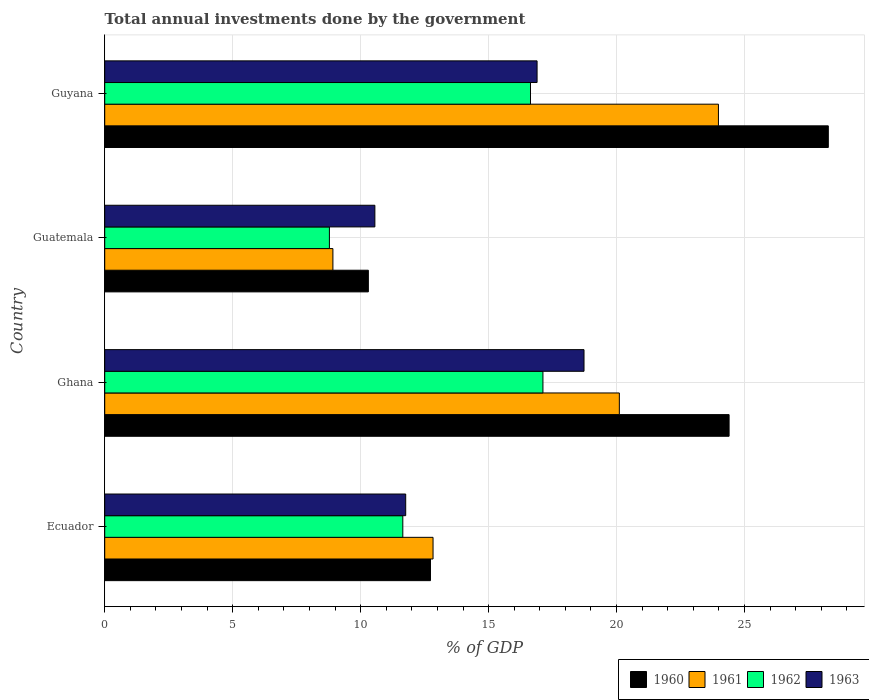How many different coloured bars are there?
Ensure brevity in your answer.  4. Are the number of bars per tick equal to the number of legend labels?
Your response must be concise. Yes. Are the number of bars on each tick of the Y-axis equal?
Offer a very short reply. Yes. What is the label of the 1st group of bars from the top?
Make the answer very short. Guyana. In how many cases, is the number of bars for a given country not equal to the number of legend labels?
Your answer should be compact. 0. What is the total annual investments done by the government in 1961 in Ghana?
Give a very brief answer. 20.11. Across all countries, what is the maximum total annual investments done by the government in 1961?
Ensure brevity in your answer.  23.98. Across all countries, what is the minimum total annual investments done by the government in 1961?
Provide a succinct answer. 8.92. In which country was the total annual investments done by the government in 1961 maximum?
Your answer should be compact. Guyana. In which country was the total annual investments done by the government in 1962 minimum?
Offer a very short reply. Guatemala. What is the total total annual investments done by the government in 1963 in the graph?
Your answer should be very brief. 57.94. What is the difference between the total annual investments done by the government in 1961 in Ecuador and that in Guatemala?
Your answer should be very brief. 3.91. What is the difference between the total annual investments done by the government in 1960 in Guatemala and the total annual investments done by the government in 1962 in Ecuador?
Make the answer very short. -1.35. What is the average total annual investments done by the government in 1961 per country?
Your response must be concise. 16.46. What is the difference between the total annual investments done by the government in 1963 and total annual investments done by the government in 1960 in Guyana?
Your response must be concise. -11.38. What is the ratio of the total annual investments done by the government in 1961 in Ghana to that in Guyana?
Your response must be concise. 0.84. Is the difference between the total annual investments done by the government in 1963 in Ghana and Guyana greater than the difference between the total annual investments done by the government in 1960 in Ghana and Guyana?
Offer a very short reply. Yes. What is the difference between the highest and the second highest total annual investments done by the government in 1961?
Your response must be concise. 3.87. What is the difference between the highest and the lowest total annual investments done by the government in 1960?
Your answer should be compact. 17.97. What does the 4th bar from the top in Ecuador represents?
Your answer should be compact. 1960. What does the 4th bar from the bottom in Ghana represents?
Keep it short and to the point. 1963. Is it the case that in every country, the sum of the total annual investments done by the government in 1962 and total annual investments done by the government in 1960 is greater than the total annual investments done by the government in 1961?
Give a very brief answer. Yes. How many bars are there?
Your response must be concise. 16. How many countries are there in the graph?
Offer a terse response. 4. Does the graph contain grids?
Give a very brief answer. Yes. What is the title of the graph?
Offer a terse response. Total annual investments done by the government. What is the label or title of the X-axis?
Provide a short and direct response. % of GDP. What is the label or title of the Y-axis?
Your answer should be very brief. Country. What is the % of GDP in 1960 in Ecuador?
Your answer should be very brief. 12.73. What is the % of GDP in 1961 in Ecuador?
Provide a succinct answer. 12.83. What is the % of GDP of 1962 in Ecuador?
Your answer should be very brief. 11.65. What is the % of GDP in 1963 in Ecuador?
Make the answer very short. 11.76. What is the % of GDP in 1960 in Ghana?
Provide a short and direct response. 24.4. What is the % of GDP of 1961 in Ghana?
Provide a short and direct response. 20.11. What is the % of GDP in 1962 in Ghana?
Ensure brevity in your answer.  17.12. What is the % of GDP in 1963 in Ghana?
Ensure brevity in your answer.  18.73. What is the % of GDP of 1960 in Guatemala?
Offer a very short reply. 10.3. What is the % of GDP in 1961 in Guatemala?
Your response must be concise. 8.92. What is the % of GDP in 1962 in Guatemala?
Your response must be concise. 8.78. What is the % of GDP in 1963 in Guatemala?
Ensure brevity in your answer.  10.56. What is the % of GDP of 1960 in Guyana?
Your answer should be compact. 28.27. What is the % of GDP of 1961 in Guyana?
Ensure brevity in your answer.  23.98. What is the % of GDP of 1962 in Guyana?
Provide a short and direct response. 16.64. What is the % of GDP of 1963 in Guyana?
Your response must be concise. 16.89. Across all countries, what is the maximum % of GDP in 1960?
Provide a succinct answer. 28.27. Across all countries, what is the maximum % of GDP in 1961?
Provide a short and direct response. 23.98. Across all countries, what is the maximum % of GDP of 1962?
Offer a very short reply. 17.12. Across all countries, what is the maximum % of GDP in 1963?
Provide a short and direct response. 18.73. Across all countries, what is the minimum % of GDP of 1960?
Your answer should be very brief. 10.3. Across all countries, what is the minimum % of GDP of 1961?
Your answer should be very brief. 8.92. Across all countries, what is the minimum % of GDP of 1962?
Offer a very short reply. 8.78. Across all countries, what is the minimum % of GDP of 1963?
Keep it short and to the point. 10.56. What is the total % of GDP in 1960 in the graph?
Your answer should be compact. 75.7. What is the total % of GDP in 1961 in the graph?
Your response must be concise. 65.83. What is the total % of GDP of 1962 in the graph?
Offer a very short reply. 54.19. What is the total % of GDP of 1963 in the graph?
Keep it short and to the point. 57.94. What is the difference between the % of GDP in 1960 in Ecuador and that in Ghana?
Offer a very short reply. -11.67. What is the difference between the % of GDP in 1961 in Ecuador and that in Ghana?
Your response must be concise. -7.28. What is the difference between the % of GDP in 1962 in Ecuador and that in Ghana?
Keep it short and to the point. -5.48. What is the difference between the % of GDP of 1963 in Ecuador and that in Ghana?
Your answer should be compact. -6.97. What is the difference between the % of GDP of 1960 in Ecuador and that in Guatemala?
Your answer should be very brief. 2.43. What is the difference between the % of GDP in 1961 in Ecuador and that in Guatemala?
Your answer should be very brief. 3.91. What is the difference between the % of GDP of 1962 in Ecuador and that in Guatemala?
Your response must be concise. 2.87. What is the difference between the % of GDP of 1963 in Ecuador and that in Guatemala?
Provide a short and direct response. 1.2. What is the difference between the % of GDP of 1960 in Ecuador and that in Guyana?
Offer a terse response. -15.54. What is the difference between the % of GDP in 1961 in Ecuador and that in Guyana?
Keep it short and to the point. -11.15. What is the difference between the % of GDP in 1962 in Ecuador and that in Guyana?
Offer a very short reply. -4.99. What is the difference between the % of GDP of 1963 in Ecuador and that in Guyana?
Your answer should be compact. -5.13. What is the difference between the % of GDP of 1960 in Ghana and that in Guatemala?
Provide a succinct answer. 14.1. What is the difference between the % of GDP of 1961 in Ghana and that in Guatemala?
Provide a succinct answer. 11.19. What is the difference between the % of GDP in 1962 in Ghana and that in Guatemala?
Offer a very short reply. 8.34. What is the difference between the % of GDP of 1963 in Ghana and that in Guatemala?
Offer a terse response. 8.17. What is the difference between the % of GDP of 1960 in Ghana and that in Guyana?
Your answer should be very brief. -3.88. What is the difference between the % of GDP of 1961 in Ghana and that in Guyana?
Make the answer very short. -3.87. What is the difference between the % of GDP in 1962 in Ghana and that in Guyana?
Give a very brief answer. 0.49. What is the difference between the % of GDP in 1963 in Ghana and that in Guyana?
Provide a succinct answer. 1.83. What is the difference between the % of GDP in 1960 in Guatemala and that in Guyana?
Your answer should be compact. -17.97. What is the difference between the % of GDP in 1961 in Guatemala and that in Guyana?
Offer a very short reply. -15.06. What is the difference between the % of GDP of 1962 in Guatemala and that in Guyana?
Provide a short and direct response. -7.86. What is the difference between the % of GDP of 1963 in Guatemala and that in Guyana?
Offer a very short reply. -6.34. What is the difference between the % of GDP in 1960 in Ecuador and the % of GDP in 1961 in Ghana?
Provide a succinct answer. -7.38. What is the difference between the % of GDP in 1960 in Ecuador and the % of GDP in 1962 in Ghana?
Your answer should be very brief. -4.39. What is the difference between the % of GDP in 1960 in Ecuador and the % of GDP in 1963 in Ghana?
Your answer should be very brief. -6. What is the difference between the % of GDP in 1961 in Ecuador and the % of GDP in 1962 in Ghana?
Keep it short and to the point. -4.29. What is the difference between the % of GDP of 1961 in Ecuador and the % of GDP of 1963 in Ghana?
Provide a short and direct response. -5.9. What is the difference between the % of GDP in 1962 in Ecuador and the % of GDP in 1963 in Ghana?
Your answer should be compact. -7.08. What is the difference between the % of GDP of 1960 in Ecuador and the % of GDP of 1961 in Guatemala?
Make the answer very short. 3.81. What is the difference between the % of GDP of 1960 in Ecuador and the % of GDP of 1962 in Guatemala?
Keep it short and to the point. 3.95. What is the difference between the % of GDP of 1960 in Ecuador and the % of GDP of 1963 in Guatemala?
Provide a succinct answer. 2.17. What is the difference between the % of GDP of 1961 in Ecuador and the % of GDP of 1962 in Guatemala?
Offer a terse response. 4.05. What is the difference between the % of GDP in 1961 in Ecuador and the % of GDP in 1963 in Guatemala?
Your response must be concise. 2.27. What is the difference between the % of GDP of 1962 in Ecuador and the % of GDP of 1963 in Guatemala?
Keep it short and to the point. 1.09. What is the difference between the % of GDP in 1960 in Ecuador and the % of GDP in 1961 in Guyana?
Offer a very short reply. -11.25. What is the difference between the % of GDP in 1960 in Ecuador and the % of GDP in 1962 in Guyana?
Your response must be concise. -3.91. What is the difference between the % of GDP in 1960 in Ecuador and the % of GDP in 1963 in Guyana?
Your answer should be compact. -4.17. What is the difference between the % of GDP in 1961 in Ecuador and the % of GDP in 1962 in Guyana?
Your response must be concise. -3.81. What is the difference between the % of GDP in 1961 in Ecuador and the % of GDP in 1963 in Guyana?
Offer a very short reply. -4.06. What is the difference between the % of GDP of 1962 in Ecuador and the % of GDP of 1963 in Guyana?
Offer a terse response. -5.25. What is the difference between the % of GDP in 1960 in Ghana and the % of GDP in 1961 in Guatemala?
Your answer should be very brief. 15.48. What is the difference between the % of GDP in 1960 in Ghana and the % of GDP in 1962 in Guatemala?
Your answer should be very brief. 15.62. What is the difference between the % of GDP of 1960 in Ghana and the % of GDP of 1963 in Guatemala?
Make the answer very short. 13.84. What is the difference between the % of GDP in 1961 in Ghana and the % of GDP in 1962 in Guatemala?
Provide a short and direct response. 11.33. What is the difference between the % of GDP in 1961 in Ghana and the % of GDP in 1963 in Guatemala?
Make the answer very short. 9.55. What is the difference between the % of GDP in 1962 in Ghana and the % of GDP in 1963 in Guatemala?
Offer a terse response. 6.57. What is the difference between the % of GDP of 1960 in Ghana and the % of GDP of 1961 in Guyana?
Your answer should be compact. 0.42. What is the difference between the % of GDP of 1960 in Ghana and the % of GDP of 1962 in Guyana?
Your answer should be very brief. 7.76. What is the difference between the % of GDP of 1960 in Ghana and the % of GDP of 1963 in Guyana?
Offer a very short reply. 7.5. What is the difference between the % of GDP of 1961 in Ghana and the % of GDP of 1962 in Guyana?
Give a very brief answer. 3.47. What is the difference between the % of GDP in 1961 in Ghana and the % of GDP in 1963 in Guyana?
Your answer should be very brief. 3.21. What is the difference between the % of GDP in 1962 in Ghana and the % of GDP in 1963 in Guyana?
Ensure brevity in your answer.  0.23. What is the difference between the % of GDP of 1960 in Guatemala and the % of GDP of 1961 in Guyana?
Provide a succinct answer. -13.68. What is the difference between the % of GDP of 1960 in Guatemala and the % of GDP of 1962 in Guyana?
Provide a succinct answer. -6.34. What is the difference between the % of GDP of 1960 in Guatemala and the % of GDP of 1963 in Guyana?
Your answer should be compact. -6.59. What is the difference between the % of GDP in 1961 in Guatemala and the % of GDP in 1962 in Guyana?
Your answer should be very brief. -7.72. What is the difference between the % of GDP of 1961 in Guatemala and the % of GDP of 1963 in Guyana?
Your response must be concise. -7.98. What is the difference between the % of GDP in 1962 in Guatemala and the % of GDP in 1963 in Guyana?
Your answer should be compact. -8.11. What is the average % of GDP of 1960 per country?
Your response must be concise. 18.92. What is the average % of GDP in 1961 per country?
Your answer should be very brief. 16.46. What is the average % of GDP in 1962 per country?
Make the answer very short. 13.55. What is the average % of GDP of 1963 per country?
Your response must be concise. 14.48. What is the difference between the % of GDP in 1960 and % of GDP in 1961 in Ecuador?
Keep it short and to the point. -0.1. What is the difference between the % of GDP of 1960 and % of GDP of 1962 in Ecuador?
Make the answer very short. 1.08. What is the difference between the % of GDP of 1960 and % of GDP of 1963 in Ecuador?
Provide a succinct answer. 0.97. What is the difference between the % of GDP of 1961 and % of GDP of 1962 in Ecuador?
Offer a terse response. 1.18. What is the difference between the % of GDP of 1961 and % of GDP of 1963 in Ecuador?
Provide a succinct answer. 1.07. What is the difference between the % of GDP of 1962 and % of GDP of 1963 in Ecuador?
Keep it short and to the point. -0.11. What is the difference between the % of GDP in 1960 and % of GDP in 1961 in Ghana?
Offer a terse response. 4.29. What is the difference between the % of GDP in 1960 and % of GDP in 1962 in Ghana?
Your answer should be compact. 7.27. What is the difference between the % of GDP of 1960 and % of GDP of 1963 in Ghana?
Provide a short and direct response. 5.67. What is the difference between the % of GDP in 1961 and % of GDP in 1962 in Ghana?
Provide a short and direct response. 2.98. What is the difference between the % of GDP of 1961 and % of GDP of 1963 in Ghana?
Ensure brevity in your answer.  1.38. What is the difference between the % of GDP of 1962 and % of GDP of 1963 in Ghana?
Ensure brevity in your answer.  -1.6. What is the difference between the % of GDP in 1960 and % of GDP in 1961 in Guatemala?
Your answer should be very brief. 1.38. What is the difference between the % of GDP of 1960 and % of GDP of 1962 in Guatemala?
Your response must be concise. 1.52. What is the difference between the % of GDP of 1960 and % of GDP of 1963 in Guatemala?
Offer a terse response. -0.26. What is the difference between the % of GDP of 1961 and % of GDP of 1962 in Guatemala?
Your answer should be very brief. 0.14. What is the difference between the % of GDP in 1961 and % of GDP in 1963 in Guatemala?
Provide a succinct answer. -1.64. What is the difference between the % of GDP in 1962 and % of GDP in 1963 in Guatemala?
Keep it short and to the point. -1.78. What is the difference between the % of GDP in 1960 and % of GDP in 1961 in Guyana?
Give a very brief answer. 4.29. What is the difference between the % of GDP in 1960 and % of GDP in 1962 in Guyana?
Offer a very short reply. 11.64. What is the difference between the % of GDP of 1960 and % of GDP of 1963 in Guyana?
Offer a terse response. 11.38. What is the difference between the % of GDP in 1961 and % of GDP in 1962 in Guyana?
Offer a very short reply. 7.34. What is the difference between the % of GDP in 1961 and % of GDP in 1963 in Guyana?
Offer a very short reply. 7.09. What is the difference between the % of GDP of 1962 and % of GDP of 1963 in Guyana?
Your answer should be compact. -0.26. What is the ratio of the % of GDP of 1960 in Ecuador to that in Ghana?
Your answer should be very brief. 0.52. What is the ratio of the % of GDP in 1961 in Ecuador to that in Ghana?
Give a very brief answer. 0.64. What is the ratio of the % of GDP of 1962 in Ecuador to that in Ghana?
Your answer should be compact. 0.68. What is the ratio of the % of GDP in 1963 in Ecuador to that in Ghana?
Keep it short and to the point. 0.63. What is the ratio of the % of GDP of 1960 in Ecuador to that in Guatemala?
Provide a short and direct response. 1.24. What is the ratio of the % of GDP in 1961 in Ecuador to that in Guatemala?
Your response must be concise. 1.44. What is the ratio of the % of GDP of 1962 in Ecuador to that in Guatemala?
Keep it short and to the point. 1.33. What is the ratio of the % of GDP in 1963 in Ecuador to that in Guatemala?
Your response must be concise. 1.11. What is the ratio of the % of GDP in 1960 in Ecuador to that in Guyana?
Your answer should be compact. 0.45. What is the ratio of the % of GDP in 1961 in Ecuador to that in Guyana?
Keep it short and to the point. 0.54. What is the ratio of the % of GDP in 1962 in Ecuador to that in Guyana?
Offer a very short reply. 0.7. What is the ratio of the % of GDP in 1963 in Ecuador to that in Guyana?
Keep it short and to the point. 0.7. What is the ratio of the % of GDP of 1960 in Ghana to that in Guatemala?
Make the answer very short. 2.37. What is the ratio of the % of GDP in 1961 in Ghana to that in Guatemala?
Make the answer very short. 2.26. What is the ratio of the % of GDP in 1962 in Ghana to that in Guatemala?
Ensure brevity in your answer.  1.95. What is the ratio of the % of GDP in 1963 in Ghana to that in Guatemala?
Your answer should be compact. 1.77. What is the ratio of the % of GDP of 1960 in Ghana to that in Guyana?
Your answer should be compact. 0.86. What is the ratio of the % of GDP of 1961 in Ghana to that in Guyana?
Offer a very short reply. 0.84. What is the ratio of the % of GDP of 1962 in Ghana to that in Guyana?
Offer a very short reply. 1.03. What is the ratio of the % of GDP in 1963 in Ghana to that in Guyana?
Give a very brief answer. 1.11. What is the ratio of the % of GDP of 1960 in Guatemala to that in Guyana?
Ensure brevity in your answer.  0.36. What is the ratio of the % of GDP of 1961 in Guatemala to that in Guyana?
Ensure brevity in your answer.  0.37. What is the ratio of the % of GDP of 1962 in Guatemala to that in Guyana?
Your answer should be compact. 0.53. What is the ratio of the % of GDP of 1963 in Guatemala to that in Guyana?
Ensure brevity in your answer.  0.62. What is the difference between the highest and the second highest % of GDP of 1960?
Your response must be concise. 3.88. What is the difference between the highest and the second highest % of GDP of 1961?
Keep it short and to the point. 3.87. What is the difference between the highest and the second highest % of GDP of 1962?
Offer a very short reply. 0.49. What is the difference between the highest and the second highest % of GDP of 1963?
Your response must be concise. 1.83. What is the difference between the highest and the lowest % of GDP of 1960?
Provide a short and direct response. 17.97. What is the difference between the highest and the lowest % of GDP of 1961?
Offer a terse response. 15.06. What is the difference between the highest and the lowest % of GDP in 1962?
Your answer should be very brief. 8.34. What is the difference between the highest and the lowest % of GDP in 1963?
Give a very brief answer. 8.17. 